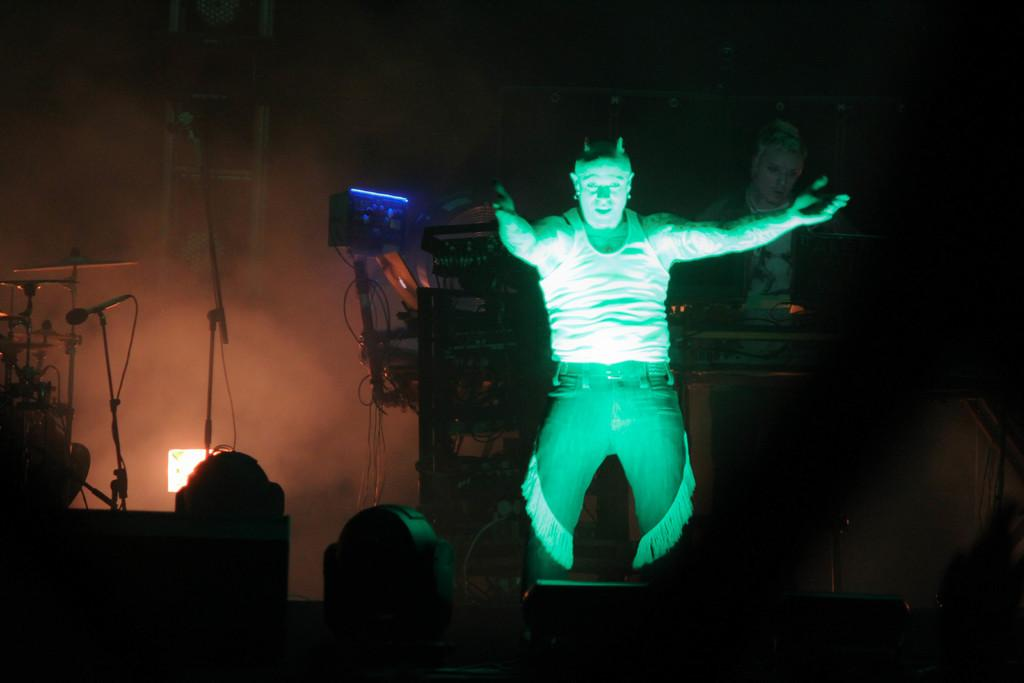Who is the main subject in the image? There is a man in the image. What is the man doing in the image? The man appears to be acting in a play. What equipment can be seen in the background of the image? There are mics and speakers in the background of the image. Can you describe the other person in the image? There is another person on the right side of the image. What type of trees can be seen in the image? There are no trees present in the image. How does the train move in the image? There is no train present in the image. 